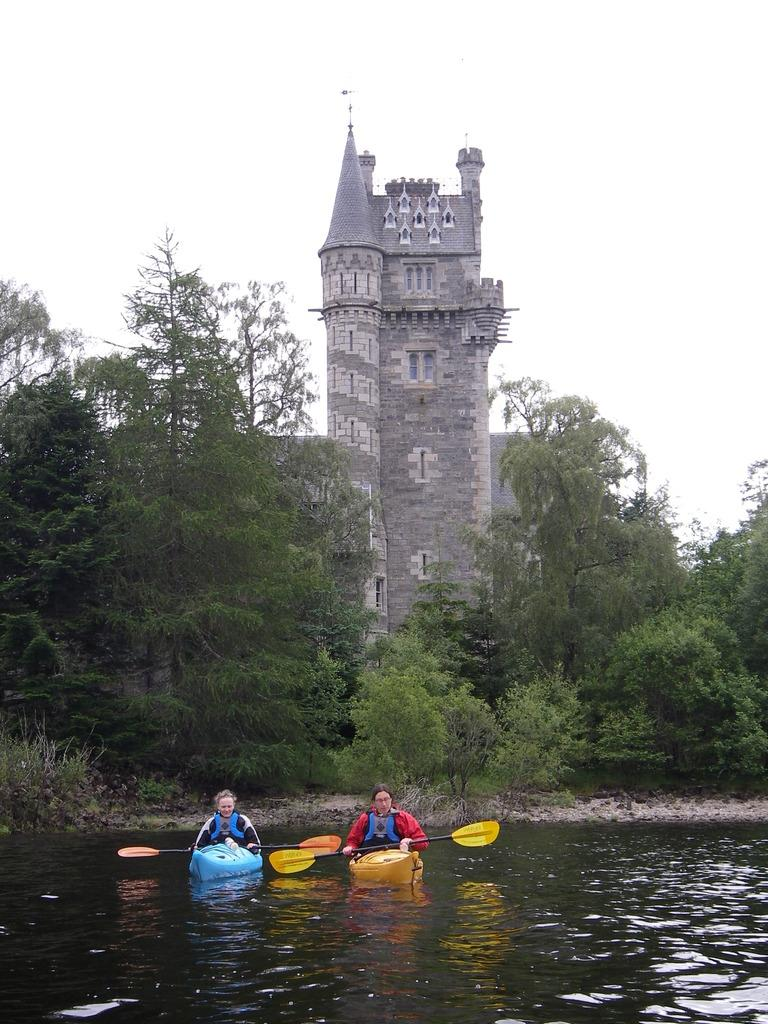How many people are in the image? There are two persons in the image, each in their own boat. What are the boats doing in the image? The boats are floating on a river. What is located at the center of the image? There is a building at the center of the image. What type of vegetation can be seen in the image? There are trees in the image. What is visible in the background of the image? The sky is visible in the background. What type of activity is the spy engaging in with the machine in the image? There is no machine or spy present in the image. The image features two persons in individual boats floating on a river, with a building at the center, trees, and a visible sky in the background. 